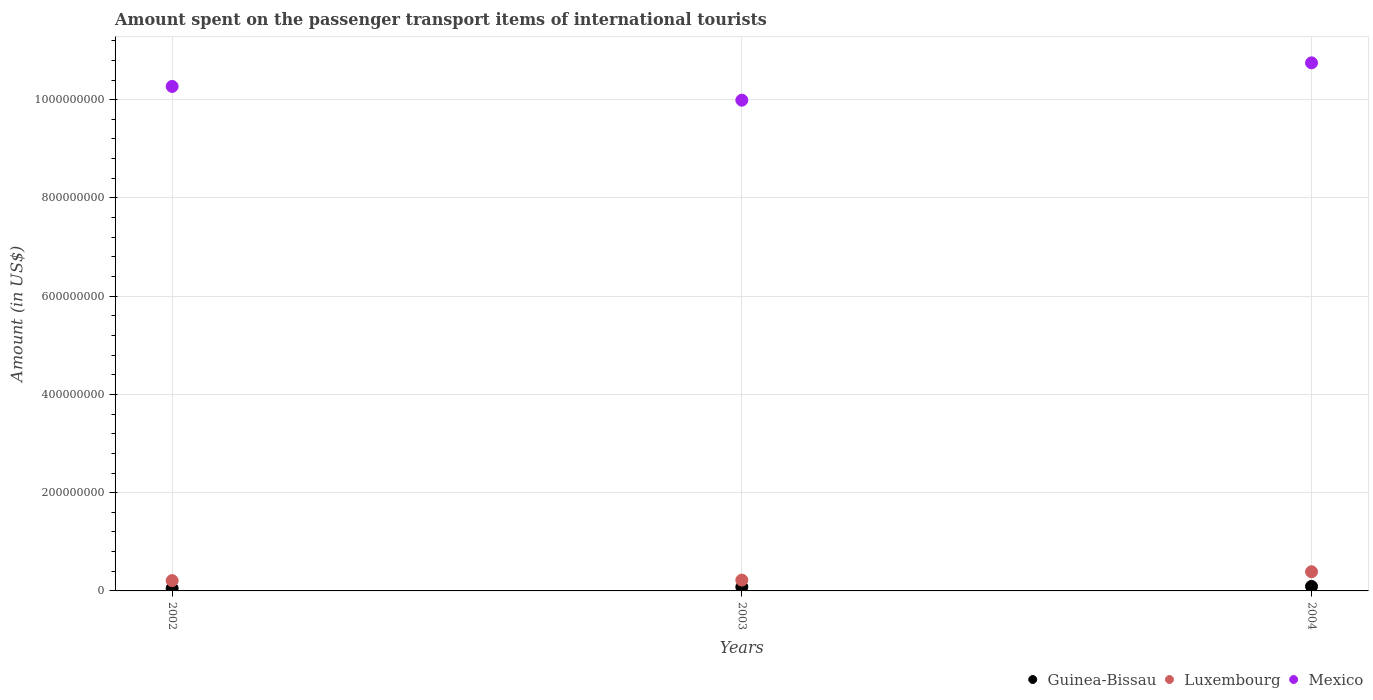What is the amount spent on the passenger transport items of international tourists in Luxembourg in 2004?
Offer a very short reply. 3.90e+07. Across all years, what is the maximum amount spent on the passenger transport items of international tourists in Luxembourg?
Your answer should be compact. 3.90e+07. Across all years, what is the minimum amount spent on the passenger transport items of international tourists in Guinea-Bissau?
Keep it short and to the point. 5.10e+06. In which year was the amount spent on the passenger transport items of international tourists in Mexico maximum?
Provide a succinct answer. 2004. In which year was the amount spent on the passenger transport items of international tourists in Mexico minimum?
Provide a short and direct response. 2003. What is the total amount spent on the passenger transport items of international tourists in Mexico in the graph?
Offer a terse response. 3.10e+09. What is the difference between the amount spent on the passenger transport items of international tourists in Mexico in 2002 and that in 2004?
Offer a terse response. -4.80e+07. What is the difference between the amount spent on the passenger transport items of international tourists in Guinea-Bissau in 2002 and the amount spent on the passenger transport items of international tourists in Mexico in 2003?
Make the answer very short. -9.94e+08. What is the average amount spent on the passenger transport items of international tourists in Luxembourg per year?
Give a very brief answer. 2.73e+07. In the year 2004, what is the difference between the amount spent on the passenger transport items of international tourists in Guinea-Bissau and amount spent on the passenger transport items of international tourists in Mexico?
Make the answer very short. -1.07e+09. In how many years, is the amount spent on the passenger transport items of international tourists in Guinea-Bissau greater than 760000000 US$?
Make the answer very short. 0. What is the ratio of the amount spent on the passenger transport items of international tourists in Mexico in 2002 to that in 2003?
Offer a terse response. 1.03. Is the amount spent on the passenger transport items of international tourists in Luxembourg in 2002 less than that in 2004?
Your answer should be very brief. Yes. Is the difference between the amount spent on the passenger transport items of international tourists in Guinea-Bissau in 2002 and 2003 greater than the difference between the amount spent on the passenger transport items of international tourists in Mexico in 2002 and 2003?
Your answer should be very brief. No. What is the difference between the highest and the second highest amount spent on the passenger transport items of international tourists in Mexico?
Offer a very short reply. 4.80e+07. What is the difference between the highest and the lowest amount spent on the passenger transport items of international tourists in Luxembourg?
Offer a terse response. 1.80e+07. Is the sum of the amount spent on the passenger transport items of international tourists in Guinea-Bissau in 2002 and 2003 greater than the maximum amount spent on the passenger transport items of international tourists in Luxembourg across all years?
Offer a terse response. No. How many dotlines are there?
Offer a terse response. 3. How many years are there in the graph?
Your answer should be compact. 3. Does the graph contain any zero values?
Your answer should be very brief. No. Where does the legend appear in the graph?
Your response must be concise. Bottom right. How many legend labels are there?
Provide a succinct answer. 3. What is the title of the graph?
Give a very brief answer. Amount spent on the passenger transport items of international tourists. What is the label or title of the X-axis?
Make the answer very short. Years. What is the Amount (in US$) in Guinea-Bissau in 2002?
Your answer should be very brief. 5.10e+06. What is the Amount (in US$) in Luxembourg in 2002?
Offer a terse response. 2.10e+07. What is the Amount (in US$) of Mexico in 2002?
Provide a short and direct response. 1.03e+09. What is the Amount (in US$) in Luxembourg in 2003?
Give a very brief answer. 2.20e+07. What is the Amount (in US$) in Mexico in 2003?
Provide a short and direct response. 9.99e+08. What is the Amount (in US$) in Guinea-Bissau in 2004?
Your answer should be compact. 9.20e+06. What is the Amount (in US$) of Luxembourg in 2004?
Offer a very short reply. 3.90e+07. What is the Amount (in US$) in Mexico in 2004?
Your answer should be very brief. 1.08e+09. Across all years, what is the maximum Amount (in US$) of Guinea-Bissau?
Offer a terse response. 9.20e+06. Across all years, what is the maximum Amount (in US$) in Luxembourg?
Keep it short and to the point. 3.90e+07. Across all years, what is the maximum Amount (in US$) in Mexico?
Offer a terse response. 1.08e+09. Across all years, what is the minimum Amount (in US$) of Guinea-Bissau?
Offer a terse response. 5.10e+06. Across all years, what is the minimum Amount (in US$) in Luxembourg?
Your response must be concise. 2.10e+07. Across all years, what is the minimum Amount (in US$) in Mexico?
Ensure brevity in your answer.  9.99e+08. What is the total Amount (in US$) of Guinea-Bissau in the graph?
Your response must be concise. 2.23e+07. What is the total Amount (in US$) in Luxembourg in the graph?
Ensure brevity in your answer.  8.20e+07. What is the total Amount (in US$) of Mexico in the graph?
Make the answer very short. 3.10e+09. What is the difference between the Amount (in US$) in Guinea-Bissau in 2002 and that in 2003?
Make the answer very short. -2.90e+06. What is the difference between the Amount (in US$) in Mexico in 2002 and that in 2003?
Your response must be concise. 2.80e+07. What is the difference between the Amount (in US$) of Guinea-Bissau in 2002 and that in 2004?
Keep it short and to the point. -4.10e+06. What is the difference between the Amount (in US$) of Luxembourg in 2002 and that in 2004?
Keep it short and to the point. -1.80e+07. What is the difference between the Amount (in US$) of Mexico in 2002 and that in 2004?
Give a very brief answer. -4.80e+07. What is the difference between the Amount (in US$) in Guinea-Bissau in 2003 and that in 2004?
Provide a succinct answer. -1.20e+06. What is the difference between the Amount (in US$) in Luxembourg in 2003 and that in 2004?
Offer a terse response. -1.70e+07. What is the difference between the Amount (in US$) in Mexico in 2003 and that in 2004?
Make the answer very short. -7.60e+07. What is the difference between the Amount (in US$) of Guinea-Bissau in 2002 and the Amount (in US$) of Luxembourg in 2003?
Offer a terse response. -1.69e+07. What is the difference between the Amount (in US$) in Guinea-Bissau in 2002 and the Amount (in US$) in Mexico in 2003?
Provide a succinct answer. -9.94e+08. What is the difference between the Amount (in US$) in Luxembourg in 2002 and the Amount (in US$) in Mexico in 2003?
Provide a short and direct response. -9.78e+08. What is the difference between the Amount (in US$) in Guinea-Bissau in 2002 and the Amount (in US$) in Luxembourg in 2004?
Provide a short and direct response. -3.39e+07. What is the difference between the Amount (in US$) in Guinea-Bissau in 2002 and the Amount (in US$) in Mexico in 2004?
Your answer should be very brief. -1.07e+09. What is the difference between the Amount (in US$) in Luxembourg in 2002 and the Amount (in US$) in Mexico in 2004?
Offer a terse response. -1.05e+09. What is the difference between the Amount (in US$) of Guinea-Bissau in 2003 and the Amount (in US$) of Luxembourg in 2004?
Your response must be concise. -3.10e+07. What is the difference between the Amount (in US$) of Guinea-Bissau in 2003 and the Amount (in US$) of Mexico in 2004?
Offer a very short reply. -1.07e+09. What is the difference between the Amount (in US$) in Luxembourg in 2003 and the Amount (in US$) in Mexico in 2004?
Provide a succinct answer. -1.05e+09. What is the average Amount (in US$) of Guinea-Bissau per year?
Make the answer very short. 7.43e+06. What is the average Amount (in US$) in Luxembourg per year?
Offer a very short reply. 2.73e+07. What is the average Amount (in US$) in Mexico per year?
Offer a terse response. 1.03e+09. In the year 2002, what is the difference between the Amount (in US$) of Guinea-Bissau and Amount (in US$) of Luxembourg?
Your response must be concise. -1.59e+07. In the year 2002, what is the difference between the Amount (in US$) of Guinea-Bissau and Amount (in US$) of Mexico?
Keep it short and to the point. -1.02e+09. In the year 2002, what is the difference between the Amount (in US$) in Luxembourg and Amount (in US$) in Mexico?
Your answer should be compact. -1.01e+09. In the year 2003, what is the difference between the Amount (in US$) in Guinea-Bissau and Amount (in US$) in Luxembourg?
Your response must be concise. -1.40e+07. In the year 2003, what is the difference between the Amount (in US$) of Guinea-Bissau and Amount (in US$) of Mexico?
Give a very brief answer. -9.91e+08. In the year 2003, what is the difference between the Amount (in US$) in Luxembourg and Amount (in US$) in Mexico?
Your answer should be very brief. -9.77e+08. In the year 2004, what is the difference between the Amount (in US$) of Guinea-Bissau and Amount (in US$) of Luxembourg?
Ensure brevity in your answer.  -2.98e+07. In the year 2004, what is the difference between the Amount (in US$) in Guinea-Bissau and Amount (in US$) in Mexico?
Your answer should be very brief. -1.07e+09. In the year 2004, what is the difference between the Amount (in US$) in Luxembourg and Amount (in US$) in Mexico?
Ensure brevity in your answer.  -1.04e+09. What is the ratio of the Amount (in US$) of Guinea-Bissau in 2002 to that in 2003?
Your answer should be very brief. 0.64. What is the ratio of the Amount (in US$) of Luxembourg in 2002 to that in 2003?
Offer a very short reply. 0.95. What is the ratio of the Amount (in US$) of Mexico in 2002 to that in 2003?
Provide a succinct answer. 1.03. What is the ratio of the Amount (in US$) in Guinea-Bissau in 2002 to that in 2004?
Provide a short and direct response. 0.55. What is the ratio of the Amount (in US$) in Luxembourg in 2002 to that in 2004?
Your answer should be very brief. 0.54. What is the ratio of the Amount (in US$) in Mexico in 2002 to that in 2004?
Provide a short and direct response. 0.96. What is the ratio of the Amount (in US$) of Guinea-Bissau in 2003 to that in 2004?
Offer a terse response. 0.87. What is the ratio of the Amount (in US$) of Luxembourg in 2003 to that in 2004?
Provide a succinct answer. 0.56. What is the ratio of the Amount (in US$) in Mexico in 2003 to that in 2004?
Offer a terse response. 0.93. What is the difference between the highest and the second highest Amount (in US$) in Guinea-Bissau?
Offer a very short reply. 1.20e+06. What is the difference between the highest and the second highest Amount (in US$) of Luxembourg?
Provide a succinct answer. 1.70e+07. What is the difference between the highest and the second highest Amount (in US$) of Mexico?
Your answer should be compact. 4.80e+07. What is the difference between the highest and the lowest Amount (in US$) of Guinea-Bissau?
Keep it short and to the point. 4.10e+06. What is the difference between the highest and the lowest Amount (in US$) of Luxembourg?
Make the answer very short. 1.80e+07. What is the difference between the highest and the lowest Amount (in US$) in Mexico?
Your answer should be very brief. 7.60e+07. 